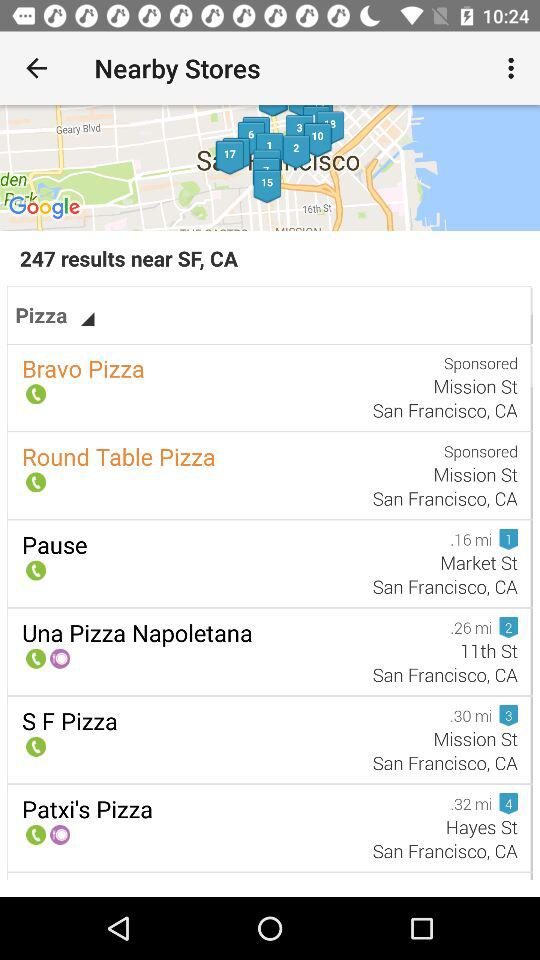What is the location of "S F Pizza"? The location of "S F Pizza" is Mission St., San Francisco, CA. 